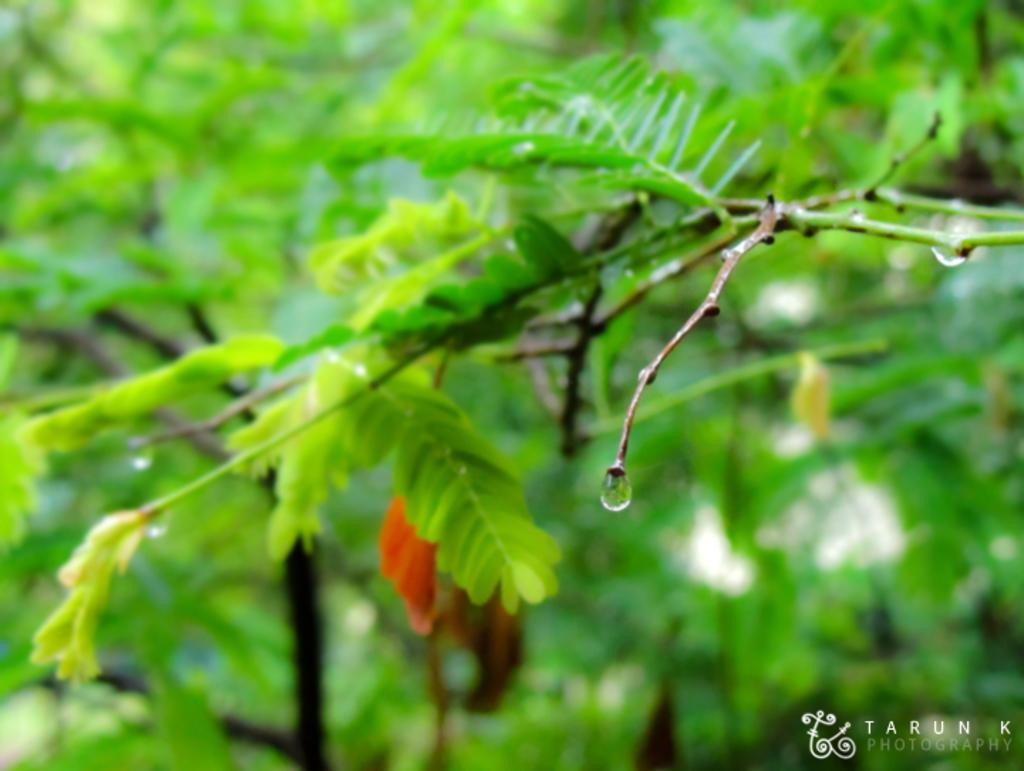What type of vegetation is present in the image? There are leaves in the image. Can you describe the condition of the leaves? There are water drops on the stem of the leaves in the image. What rule is being enforced in the image? There is no rule being enforced in the image; it features leaves with water drops on the stem. What type of house is visible in the image? There is no house present in the image; it only features leaves with water drops on the stem. 